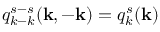<formula> <loc_0><loc_0><loc_500><loc_500>q _ { k - k } ^ { s - s } ( { k } , - { k } ) = q _ { k } ^ { s } ( { k } )</formula> 